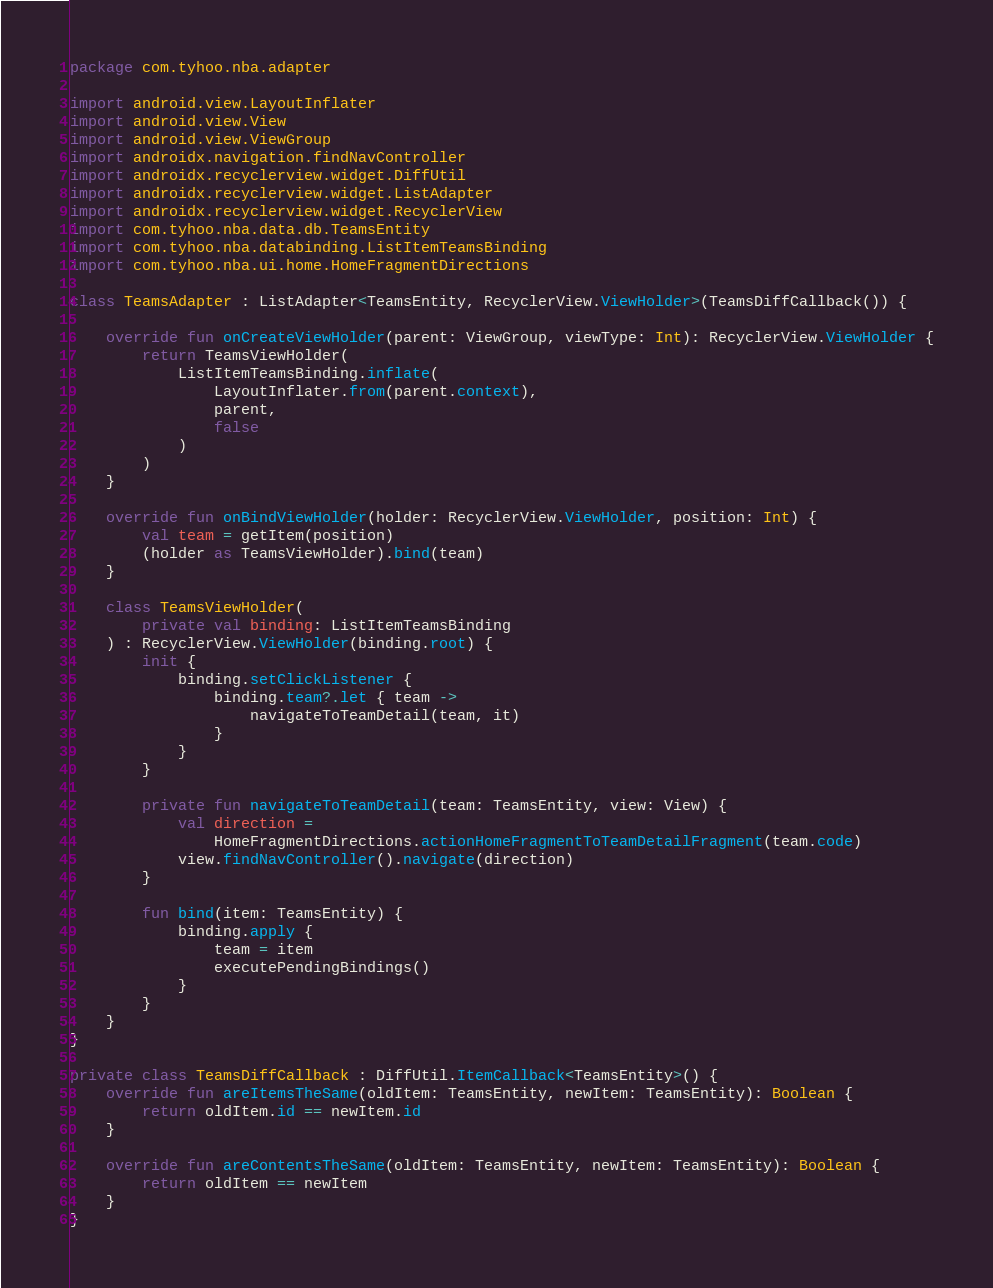<code> <loc_0><loc_0><loc_500><loc_500><_Kotlin_>package com.tyhoo.nba.adapter

import android.view.LayoutInflater
import android.view.View
import android.view.ViewGroup
import androidx.navigation.findNavController
import androidx.recyclerview.widget.DiffUtil
import androidx.recyclerview.widget.ListAdapter
import androidx.recyclerview.widget.RecyclerView
import com.tyhoo.nba.data.db.TeamsEntity
import com.tyhoo.nba.databinding.ListItemTeamsBinding
import com.tyhoo.nba.ui.home.HomeFragmentDirections

class TeamsAdapter : ListAdapter<TeamsEntity, RecyclerView.ViewHolder>(TeamsDiffCallback()) {

    override fun onCreateViewHolder(parent: ViewGroup, viewType: Int): RecyclerView.ViewHolder {
        return TeamsViewHolder(
            ListItemTeamsBinding.inflate(
                LayoutInflater.from(parent.context),
                parent,
                false
            )
        )
    }

    override fun onBindViewHolder(holder: RecyclerView.ViewHolder, position: Int) {
        val team = getItem(position)
        (holder as TeamsViewHolder).bind(team)
    }

    class TeamsViewHolder(
        private val binding: ListItemTeamsBinding
    ) : RecyclerView.ViewHolder(binding.root) {
        init {
            binding.setClickListener {
                binding.team?.let { team ->
                    navigateToTeamDetail(team, it)
                }
            }
        }

        private fun navigateToTeamDetail(team: TeamsEntity, view: View) {
            val direction =
                HomeFragmentDirections.actionHomeFragmentToTeamDetailFragment(team.code)
            view.findNavController().navigate(direction)
        }

        fun bind(item: TeamsEntity) {
            binding.apply {
                team = item
                executePendingBindings()
            }
        }
    }
}

private class TeamsDiffCallback : DiffUtil.ItemCallback<TeamsEntity>() {
    override fun areItemsTheSame(oldItem: TeamsEntity, newItem: TeamsEntity): Boolean {
        return oldItem.id == newItem.id
    }

    override fun areContentsTheSame(oldItem: TeamsEntity, newItem: TeamsEntity): Boolean {
        return oldItem == newItem
    }
}</code> 